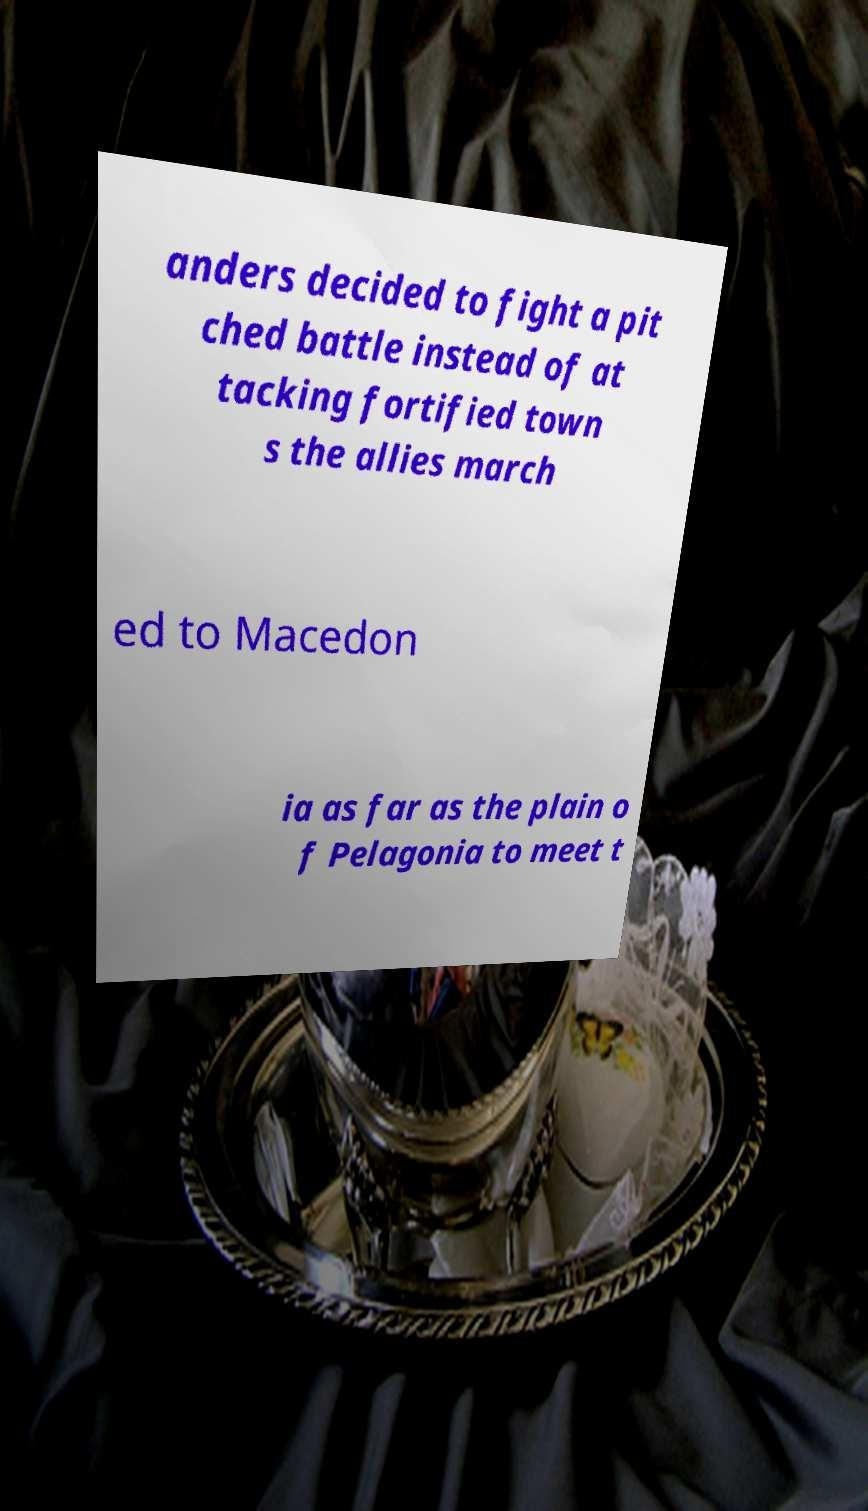What messages or text are displayed in this image? I need them in a readable, typed format. anders decided to fight a pit ched battle instead of at tacking fortified town s the allies march ed to Macedon ia as far as the plain o f Pelagonia to meet t 